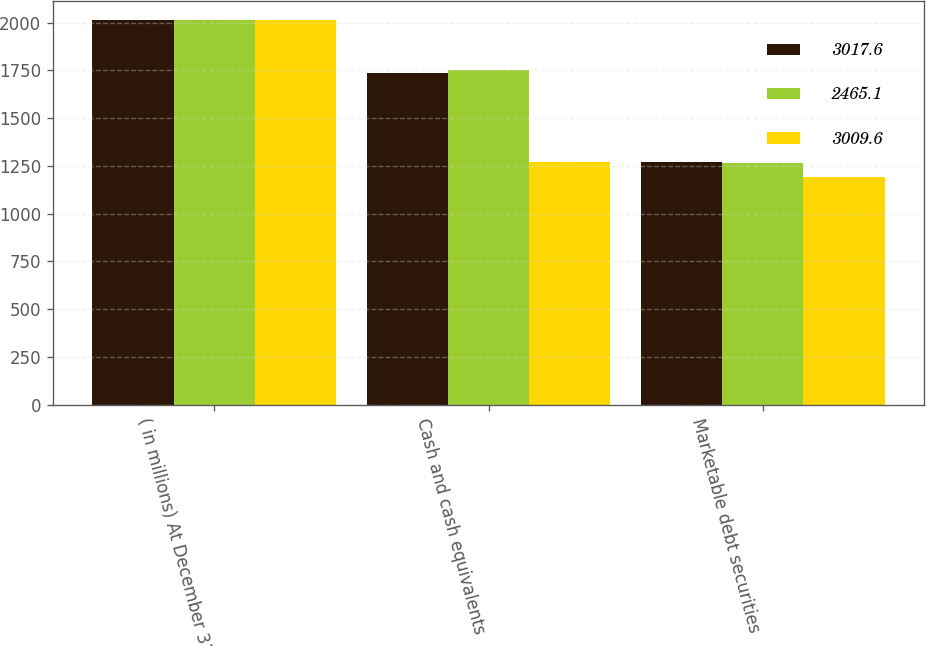Convert chart. <chart><loc_0><loc_0><loc_500><loc_500><stacked_bar_chart><ecel><fcel>( in millions) At December 31<fcel>Cash and cash equivalents<fcel>Marketable debt securities<nl><fcel>3017.6<fcel>2014<fcel>1737.6<fcel>1272<nl><fcel>2465.1<fcel>2013<fcel>1750.1<fcel>1267.5<nl><fcel>3009.6<fcel>2012<fcel>1272.4<fcel>1192.7<nl></chart> 